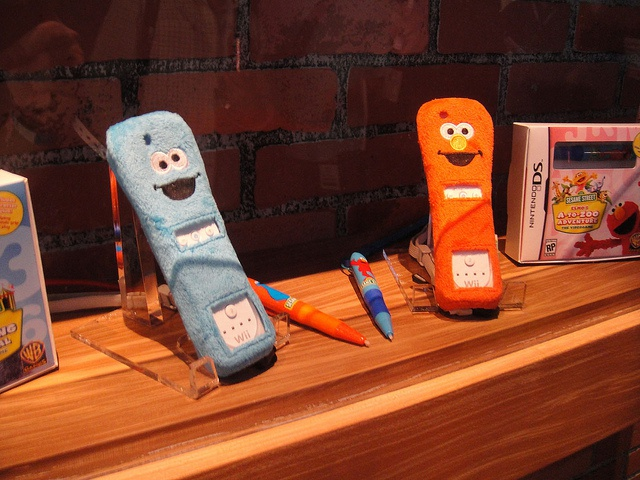Describe the objects in this image and their specific colors. I can see remote in black, darkgray, lightgray, and gray tones and remote in black, red, tan, and brown tones in this image. 